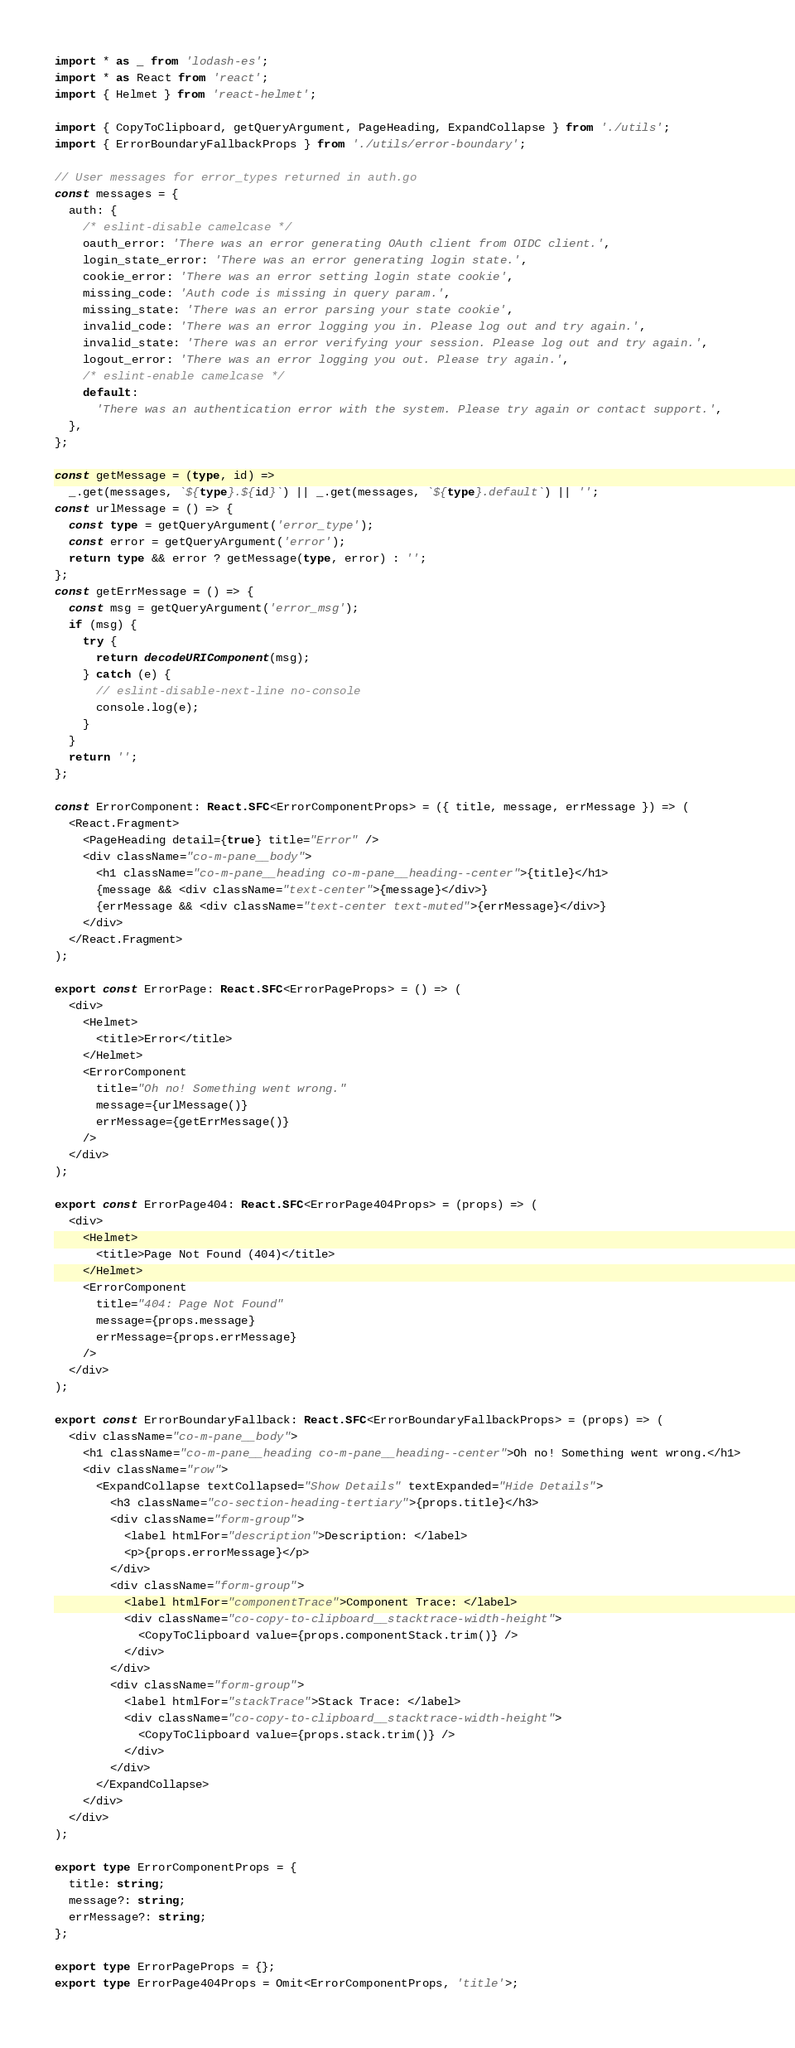<code> <loc_0><loc_0><loc_500><loc_500><_TypeScript_>import * as _ from 'lodash-es';
import * as React from 'react';
import { Helmet } from 'react-helmet';

import { CopyToClipboard, getQueryArgument, PageHeading, ExpandCollapse } from './utils';
import { ErrorBoundaryFallbackProps } from './utils/error-boundary';

// User messages for error_types returned in auth.go
const messages = {
  auth: {
    /* eslint-disable camelcase */
    oauth_error: 'There was an error generating OAuth client from OIDC client.',
    login_state_error: 'There was an error generating login state.',
    cookie_error: 'There was an error setting login state cookie',
    missing_code: 'Auth code is missing in query param.',
    missing_state: 'There was an error parsing your state cookie',
    invalid_code: 'There was an error logging you in. Please log out and try again.',
    invalid_state: 'There was an error verifying your session. Please log out and try again.',
    logout_error: 'There was an error logging you out. Please try again.',
    /* eslint-enable camelcase */
    default:
      'There was an authentication error with the system. Please try again or contact support.',
  },
};

const getMessage = (type, id) =>
  _.get(messages, `${type}.${id}`) || _.get(messages, `${type}.default`) || '';
const urlMessage = () => {
  const type = getQueryArgument('error_type');
  const error = getQueryArgument('error');
  return type && error ? getMessage(type, error) : '';
};
const getErrMessage = () => {
  const msg = getQueryArgument('error_msg');
  if (msg) {
    try {
      return decodeURIComponent(msg);
    } catch (e) {
      // eslint-disable-next-line no-console
      console.log(e);
    }
  }
  return '';
};

const ErrorComponent: React.SFC<ErrorComponentProps> = ({ title, message, errMessage }) => (
  <React.Fragment>
    <PageHeading detail={true} title="Error" />
    <div className="co-m-pane__body">
      <h1 className="co-m-pane__heading co-m-pane__heading--center">{title}</h1>
      {message && <div className="text-center">{message}</div>}
      {errMessage && <div className="text-center text-muted">{errMessage}</div>}
    </div>
  </React.Fragment>
);

export const ErrorPage: React.SFC<ErrorPageProps> = () => (
  <div>
    <Helmet>
      <title>Error</title>
    </Helmet>
    <ErrorComponent
      title="Oh no! Something went wrong."
      message={urlMessage()}
      errMessage={getErrMessage()}
    />
  </div>
);

export const ErrorPage404: React.SFC<ErrorPage404Props> = (props) => (
  <div>
    <Helmet>
      <title>Page Not Found (404)</title>
    </Helmet>
    <ErrorComponent
      title="404: Page Not Found"
      message={props.message}
      errMessage={props.errMessage}
    />
  </div>
);

export const ErrorBoundaryFallback: React.SFC<ErrorBoundaryFallbackProps> = (props) => (
  <div className="co-m-pane__body">
    <h1 className="co-m-pane__heading co-m-pane__heading--center">Oh no! Something went wrong.</h1>
    <div className="row">
      <ExpandCollapse textCollapsed="Show Details" textExpanded="Hide Details">
        <h3 className="co-section-heading-tertiary">{props.title}</h3>
        <div className="form-group">
          <label htmlFor="description">Description: </label>
          <p>{props.errorMessage}</p>
        </div>
        <div className="form-group">
          <label htmlFor="componentTrace">Component Trace: </label>
          <div className="co-copy-to-clipboard__stacktrace-width-height">
            <CopyToClipboard value={props.componentStack.trim()} />
          </div>
        </div>
        <div className="form-group">
          <label htmlFor="stackTrace">Stack Trace: </label>
          <div className="co-copy-to-clipboard__stacktrace-width-height">
            <CopyToClipboard value={props.stack.trim()} />
          </div>
        </div>
      </ExpandCollapse>
    </div>
  </div>
);

export type ErrorComponentProps = {
  title: string;
  message?: string;
  errMessage?: string;
};

export type ErrorPageProps = {};
export type ErrorPage404Props = Omit<ErrorComponentProps, 'title'>;
</code> 